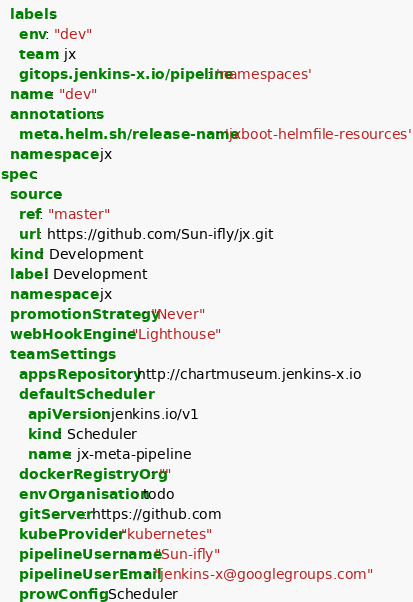<code> <loc_0><loc_0><loc_500><loc_500><_YAML_>  labels:
    env: "dev"
    team: jx
    gitops.jenkins-x.io/pipeline: 'namespaces'
  name: "dev"
  annotations:
    meta.helm.sh/release-name: 'jxboot-helmfile-resources'
  namespace: jx
spec:
  source:
    ref: "master"
    url: https://github.com/Sun-ifly/jx.git
  kind: Development
  label: Development
  namespace: jx
  promotionStrategy: "Never"
  webHookEngine: "Lighthouse"
  teamSettings:
    appsRepository: http://chartmuseum.jenkins-x.io
    defaultScheduler:
      apiVersion: jenkins.io/v1
      kind: Scheduler
      name: jx-meta-pipeline
    dockerRegistryOrg: ""
    envOrganisation: todo
    gitServer: https://github.com
    kubeProvider: "kubernetes"
    pipelineUsername: "Sun-ifly"
    pipelineUserEmail: "jenkins-x@googlegroups.com"
    prowConfig: Scheduler
</code> 